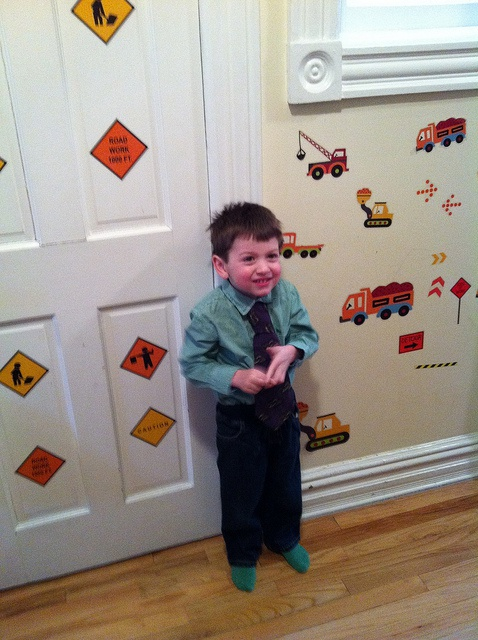Describe the objects in this image and their specific colors. I can see people in beige, black, gray, and teal tones and tie in beige, black, and purple tones in this image. 